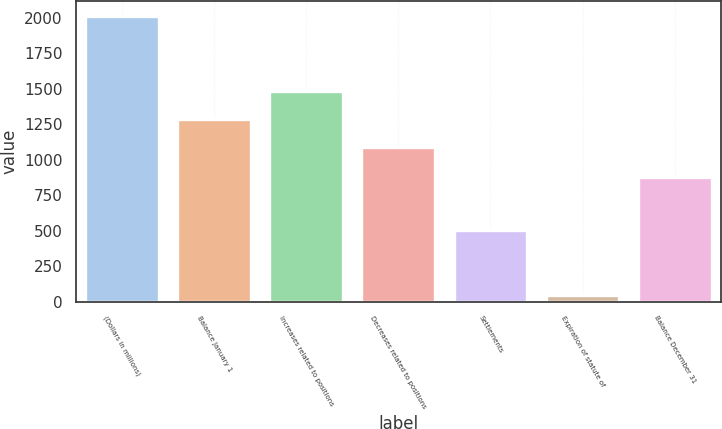Convert chart to OTSL. <chart><loc_0><loc_0><loc_500><loc_500><bar_chart><fcel>(Dollars in millions)<fcel>Balance January 1<fcel>Increases related to positions<fcel>Decreases related to positions<fcel>Settlements<fcel>Expiration of statute of<fcel>Balance December 31<nl><fcel>2016<fcel>1287.8<fcel>1484.6<fcel>1091<fcel>503<fcel>48<fcel>875<nl></chart> 